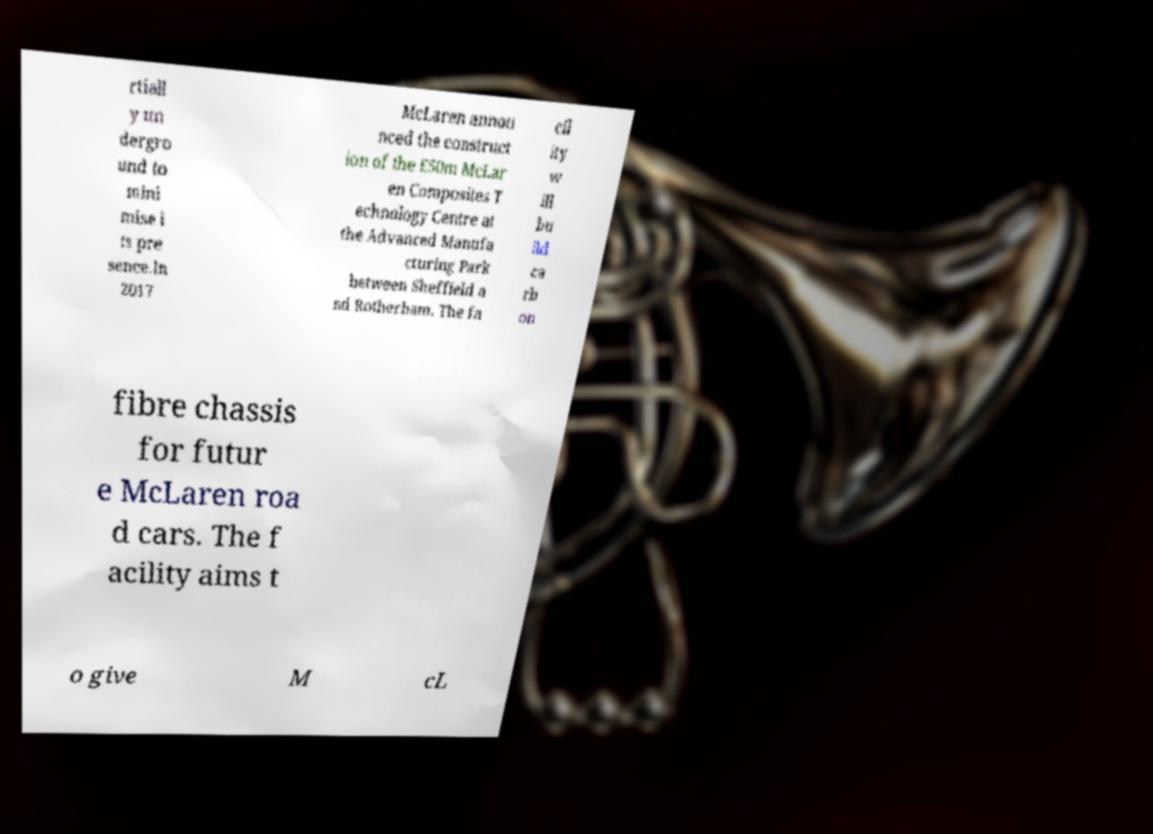Please read and relay the text visible in this image. What does it say? rtiall y un dergro und to mini mise i ts pre sence.In 2017 McLaren annou nced the construct ion of the £50m McLar en Composites T echnology Centre at the Advanced Manufa cturing Park between Sheffield a nd Rotherham. The fa cil ity w ill bu ild ca rb on fibre chassis for futur e McLaren roa d cars. The f acility aims t o give M cL 